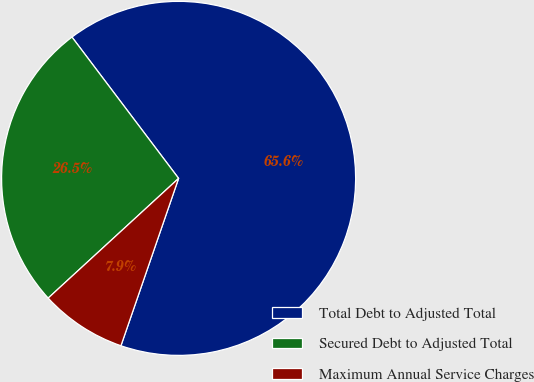<chart> <loc_0><loc_0><loc_500><loc_500><pie_chart><fcel>Total Debt to Adjusted Total<fcel>Secured Debt to Adjusted Total<fcel>Maximum Annual Service Charges<nl><fcel>65.57%<fcel>26.53%<fcel>7.9%<nl></chart> 